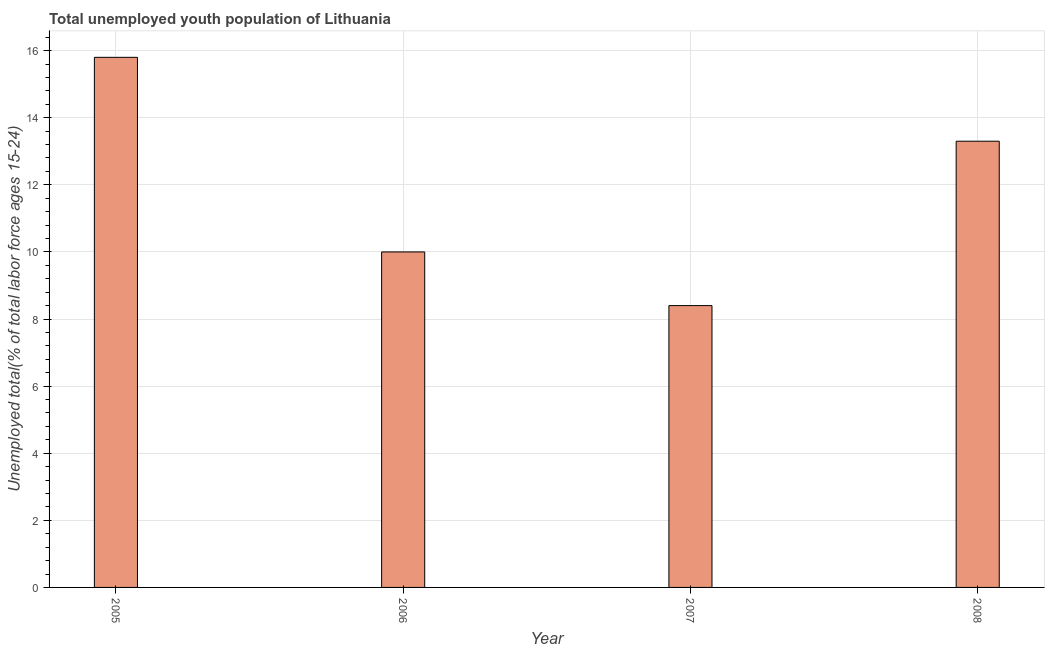What is the title of the graph?
Offer a very short reply. Total unemployed youth population of Lithuania. What is the label or title of the Y-axis?
Offer a terse response. Unemployed total(% of total labor force ages 15-24). What is the unemployed youth in 2005?
Ensure brevity in your answer.  15.8. Across all years, what is the maximum unemployed youth?
Your response must be concise. 15.8. Across all years, what is the minimum unemployed youth?
Ensure brevity in your answer.  8.4. What is the sum of the unemployed youth?
Provide a succinct answer. 47.5. What is the average unemployed youth per year?
Ensure brevity in your answer.  11.88. What is the median unemployed youth?
Ensure brevity in your answer.  11.65. What is the ratio of the unemployed youth in 2005 to that in 2006?
Your response must be concise. 1.58. Is the unemployed youth in 2005 less than that in 2007?
Keep it short and to the point. No. What is the difference between the highest and the second highest unemployed youth?
Keep it short and to the point. 2.5. Is the sum of the unemployed youth in 2005 and 2007 greater than the maximum unemployed youth across all years?
Keep it short and to the point. Yes. Are the values on the major ticks of Y-axis written in scientific E-notation?
Provide a short and direct response. No. What is the Unemployed total(% of total labor force ages 15-24) in 2005?
Provide a succinct answer. 15.8. What is the Unemployed total(% of total labor force ages 15-24) of 2006?
Keep it short and to the point. 10. What is the Unemployed total(% of total labor force ages 15-24) of 2007?
Your answer should be very brief. 8.4. What is the Unemployed total(% of total labor force ages 15-24) in 2008?
Keep it short and to the point. 13.3. What is the difference between the Unemployed total(% of total labor force ages 15-24) in 2005 and 2006?
Ensure brevity in your answer.  5.8. What is the difference between the Unemployed total(% of total labor force ages 15-24) in 2005 and 2007?
Provide a succinct answer. 7.4. What is the difference between the Unemployed total(% of total labor force ages 15-24) in 2005 and 2008?
Provide a succinct answer. 2.5. What is the difference between the Unemployed total(% of total labor force ages 15-24) in 2006 and 2007?
Your answer should be compact. 1.6. What is the difference between the Unemployed total(% of total labor force ages 15-24) in 2006 and 2008?
Your answer should be very brief. -3.3. What is the difference between the Unemployed total(% of total labor force ages 15-24) in 2007 and 2008?
Offer a very short reply. -4.9. What is the ratio of the Unemployed total(% of total labor force ages 15-24) in 2005 to that in 2006?
Your answer should be compact. 1.58. What is the ratio of the Unemployed total(% of total labor force ages 15-24) in 2005 to that in 2007?
Ensure brevity in your answer.  1.88. What is the ratio of the Unemployed total(% of total labor force ages 15-24) in 2005 to that in 2008?
Your answer should be compact. 1.19. What is the ratio of the Unemployed total(% of total labor force ages 15-24) in 2006 to that in 2007?
Ensure brevity in your answer.  1.19. What is the ratio of the Unemployed total(% of total labor force ages 15-24) in 2006 to that in 2008?
Ensure brevity in your answer.  0.75. What is the ratio of the Unemployed total(% of total labor force ages 15-24) in 2007 to that in 2008?
Your answer should be compact. 0.63. 